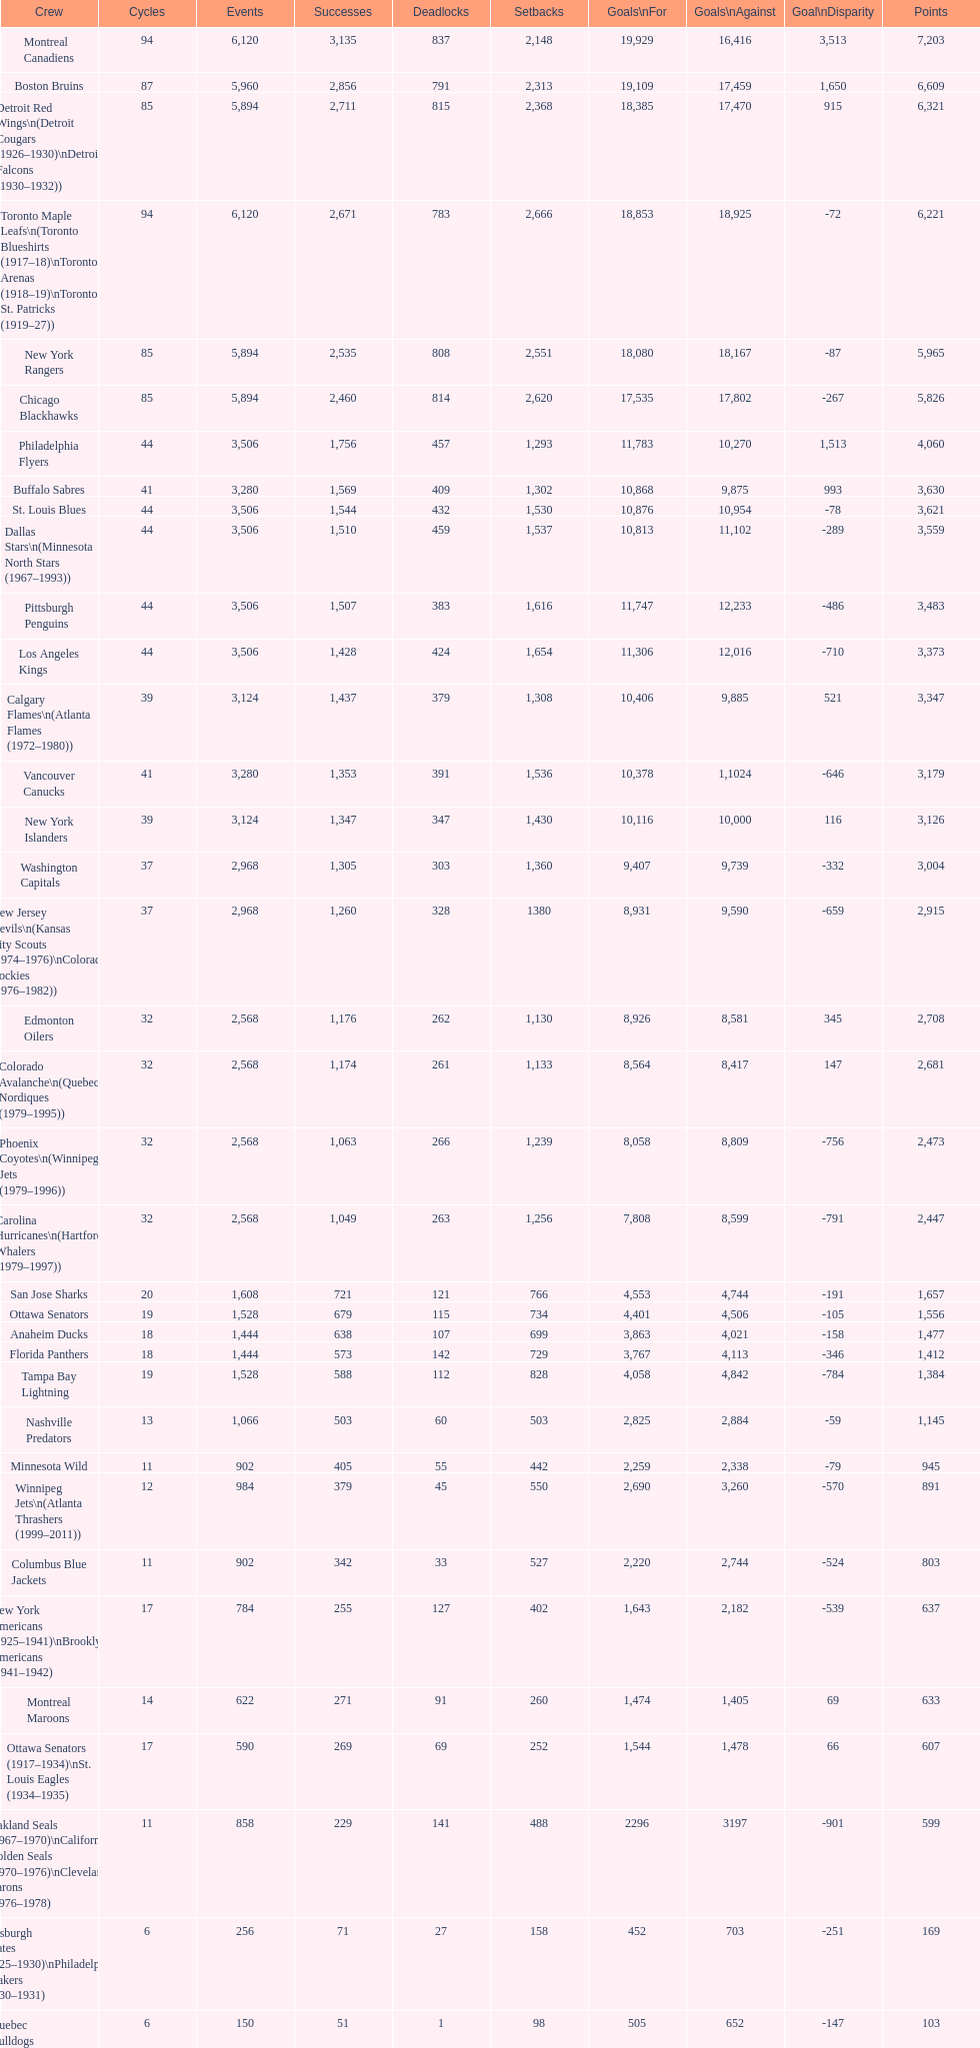Who is at the top of the list? Montreal Canadiens. 